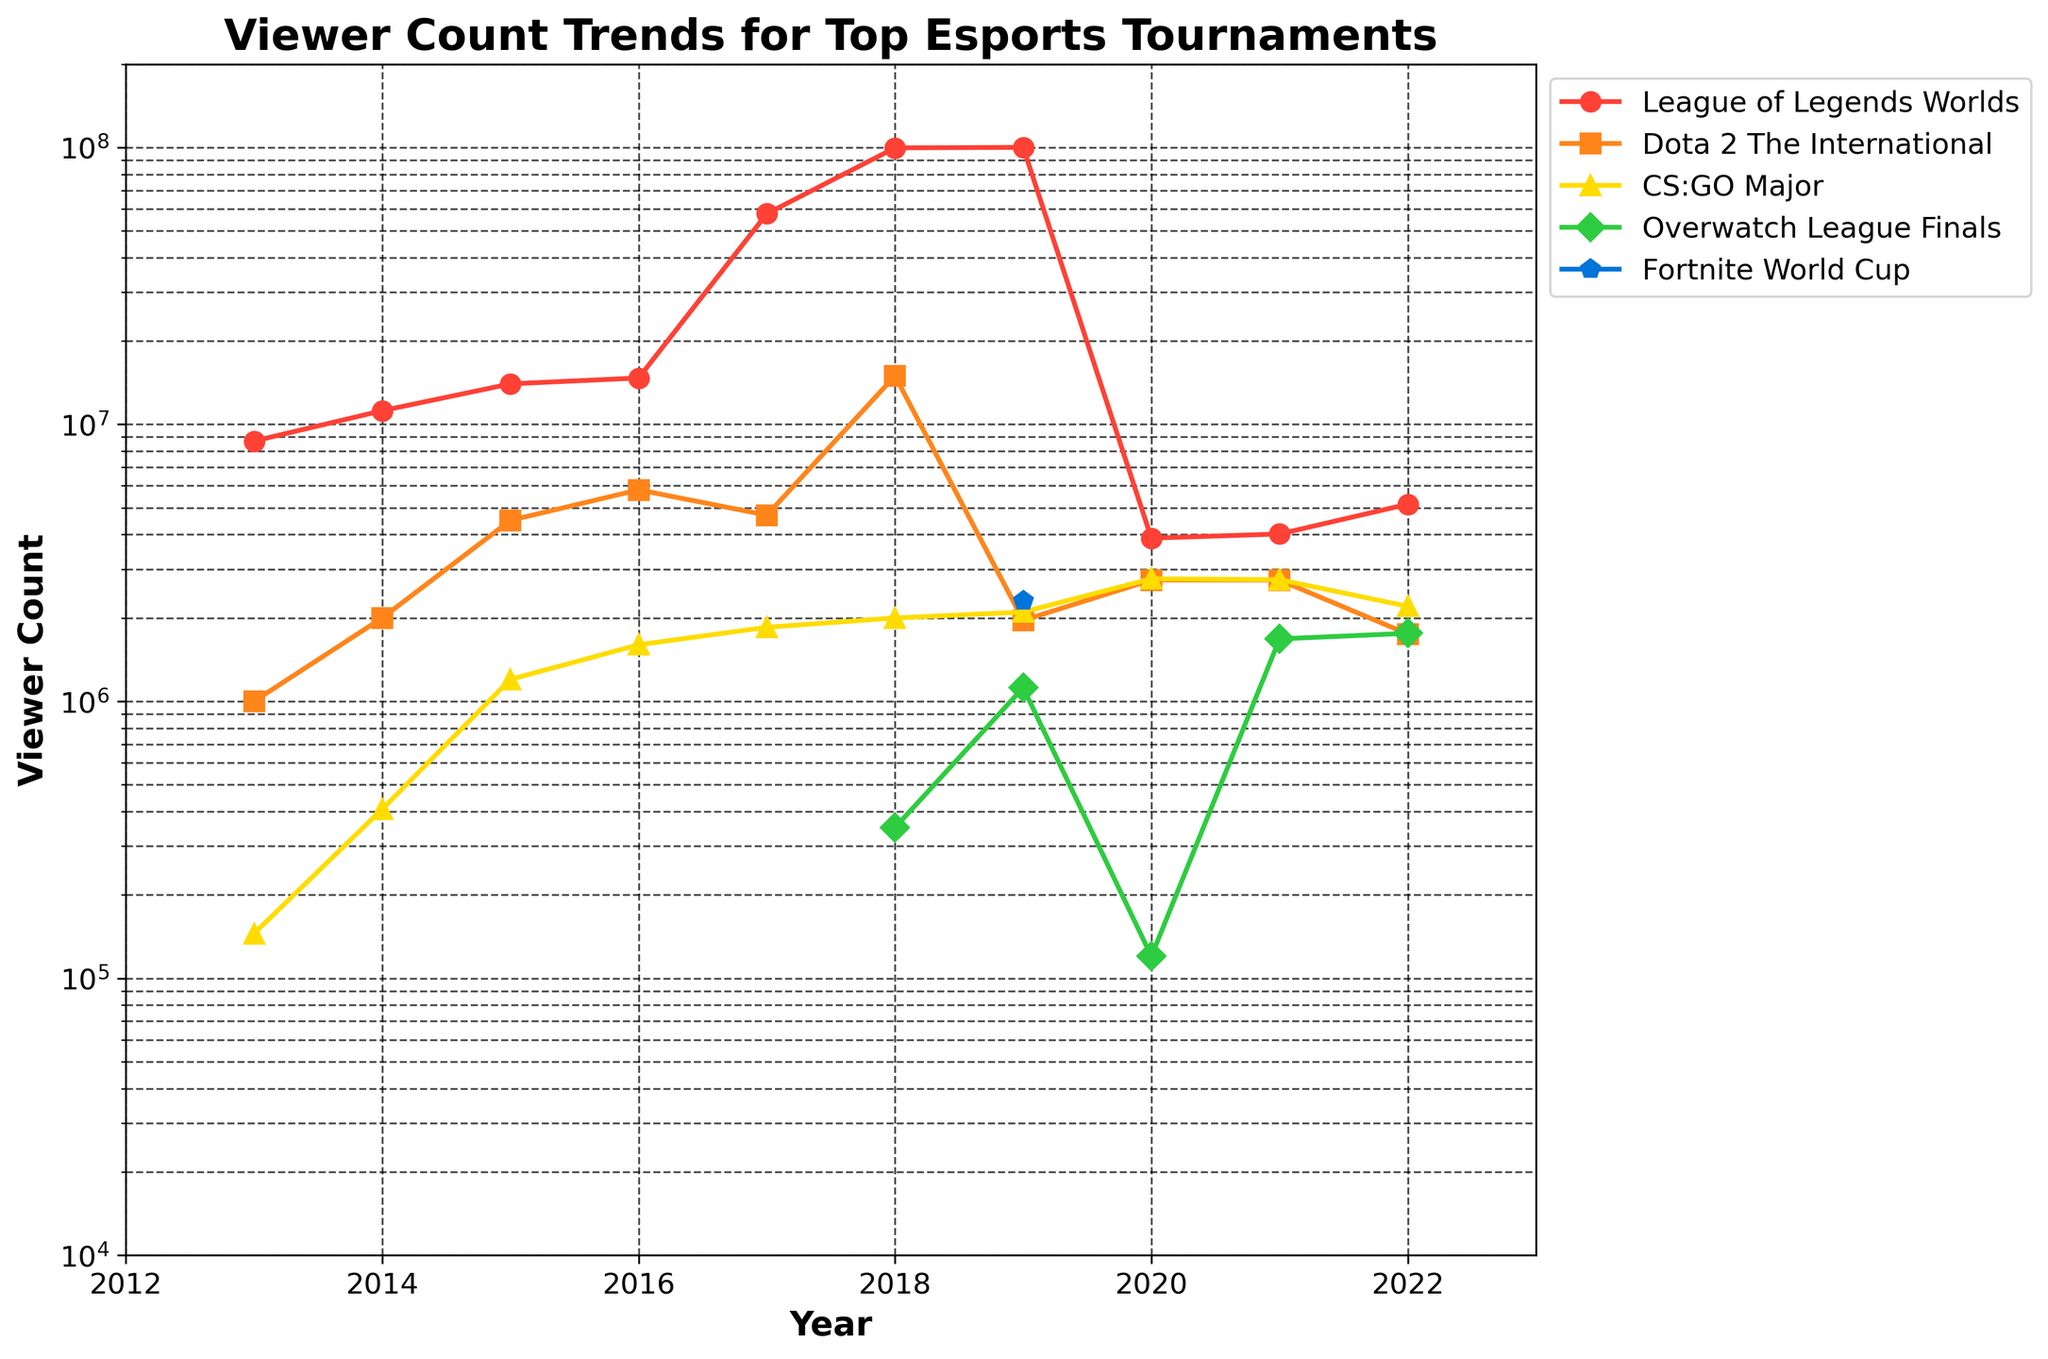What has been the overall trend for the viewer count of the League of Legends Worlds tournament from 2013 to 2022? The League of Legends Worlds tournament has seen a significant increase in viewer count over the years, starting from 8,700,000 in 2013 and peaking at 100,000,000 in 2019. After that, there was a drop to around 4-5 million viewers in 2020 and beyond. This indicates an initial steady growth, a peak in 2019, followed by a decline.
Answer: Increase, peak in 2019, followed by a decline In 2018, which tournament had the highest viewer count, and what was the value? By looking at the year 2018 on the plot, the League of Legends Worlds tournament had the highest viewer count among all tournaments, with a value of 99,600,000.
Answer: League of Legends Worlds, 99,600,000 Compare the viewer count for the Fortnite World Cup and Overwatch League Finals in 2019. Which was higher, and by how much? In 2019, the Fortnite World Cup had a viewer count of 2,300,000 while the Overwatch League Finals had a viewer count of 1,120,000. Therefore, the Fortnite World Cup had 1,180,000 more viewers than the Overwatch League Finals.
Answer: Fortnite World Cup by 1,180,000 What is the range of viewer counts for the CS:GO Major tournament from 2013 to 2022? The viewer count for the CS:GO Major tournament ranged from 145,000 in 2013 to 2,774,850 in 2021.
Answer: 145,000 to 2,774,850 Which tournament showed the most dramatic increase in viewers between any two consecutive years? Between 2016 and 2017, the League of Legends Worlds tournament showed the most dramatic increase in viewers, from 14,700,000 to 57,600,000, a difference of 42,900,000.
Answer: League of Legends Worlds, 42,900,000 increase In which years did the Dota 2 The International tournament have a viewer count above 5 million? The Dota 2 The International tournament had a viewer count above 5 million in the years 2016 and 2018, with 5,800,000 and 14,960,000 viewers, respectively.
Answer: 2016 and 2018 What was the viewer count for the League of Legends Worlds tournament in 2020, and how does it compare to its peak year? In 2020, the League of Legends Worlds tournament had a viewer count of 3,882,470. Compared to its peak year in 2019 with 100,000,000 viewers, it saw a significant decrease of 96,117,530 viewers.
Answer: 3,882,470, much lower than peak Considering only the years provided, what is the average viewer count for the Overwatch League Finals? The Overwatch League Finals had viewer counts available for 2018 (350,000), 2019 (1,120,000), 2020 (120,000), 2021 (1,680,000), and 2022 (1,760,000). Summing these values gives 5,030,000. Dividing by the 5 years, the average viewer count is 1,006,000.
Answer: 1,006,000 How many tournaments had a viewer count greater than 2 million in 2020? In 2020, the tournaments with viewer counts greater than 2 million were CS:GO Major (2,770,000). Only one tournament crossed the 2 million mark that year.
Answer: 1 Which tournament had the least consistent viewer count across the years, and why? The League of Legends Worlds tournament had the least consistent viewer count. It showed significant peaks and troughs, with a high of 100,000,000 in 2019 and a drop to around 4-5 million in 2020 and beyond, indicating large variability.
Answer: League of Legends Worlds, highly variable viewer count 